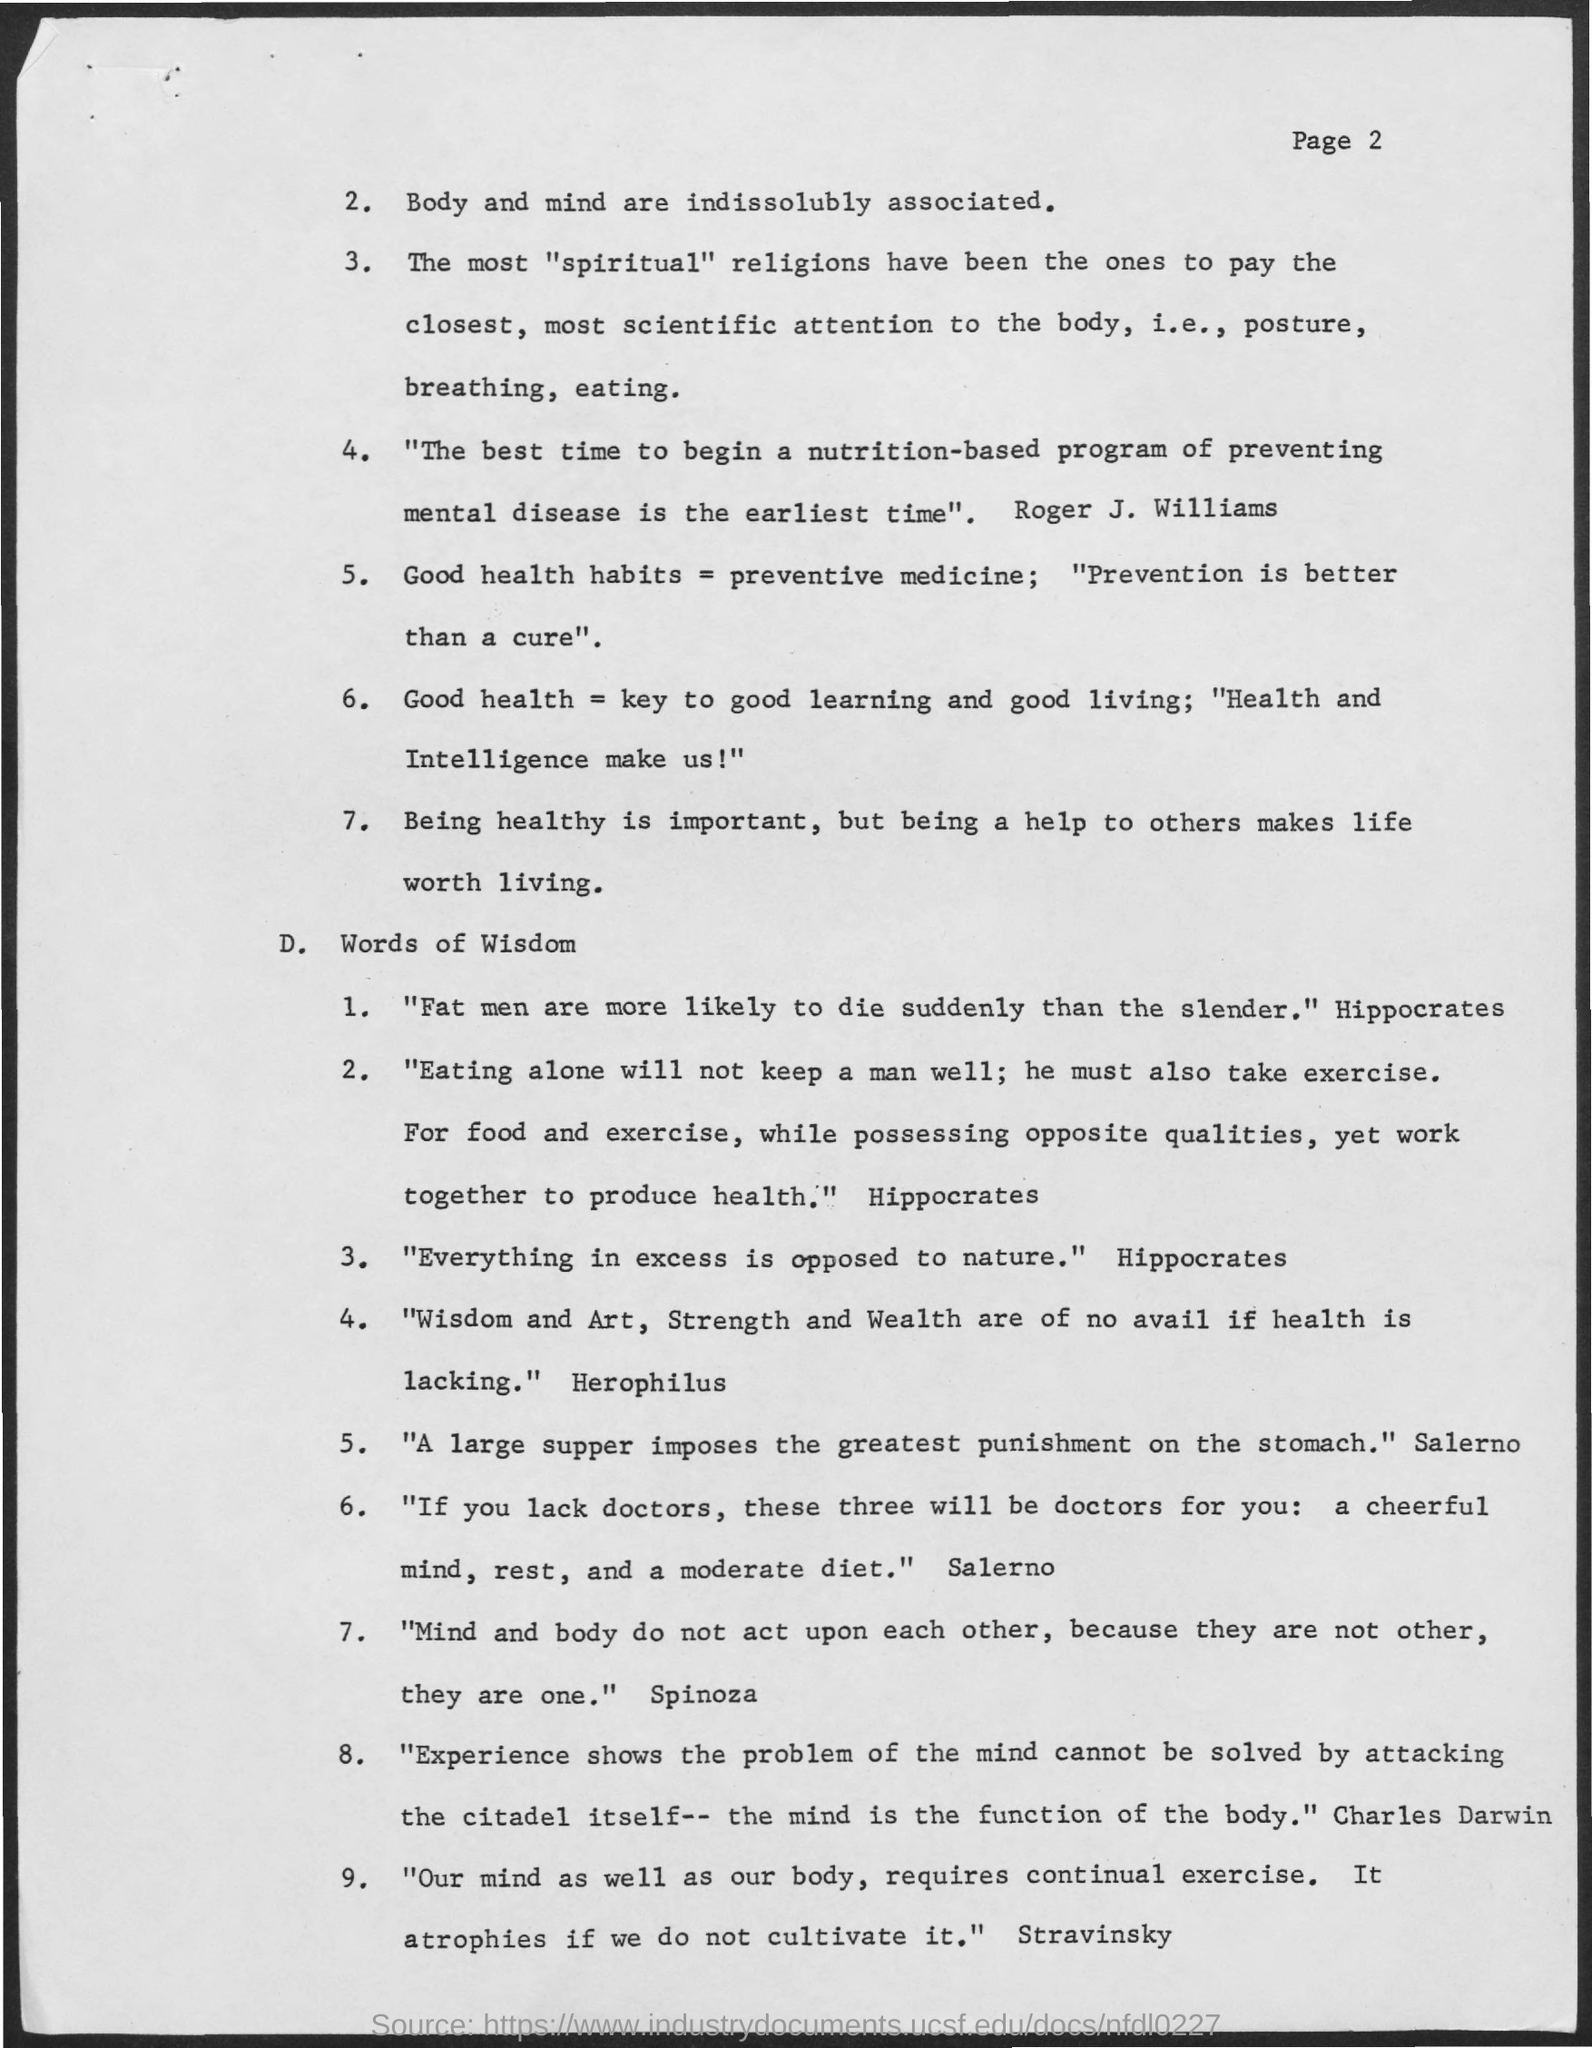"fat men are more likely to die suddenly than the slender" was written by ?
Keep it short and to the point. Hippocrates. "everything in excess is opposed to nature " is written by ?
Give a very brief answer. Hippocrates. "a large supper imposes the greatest punishment on the stomach'"was written by ?
Your answer should be compact. Salerno. "mind and body do not act upon each other,because they are not other,they are one "was written by?
Your answer should be compact. Spinoza. "wisdom and art,strength and wealth are of no avail if health is lacking " was written by ?
Your answer should be very brief. Herophilus. 